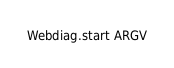Convert code to text. <code><loc_0><loc_0><loc_500><loc_500><_Ruby_>
Webdiag.start ARGV
</code> 